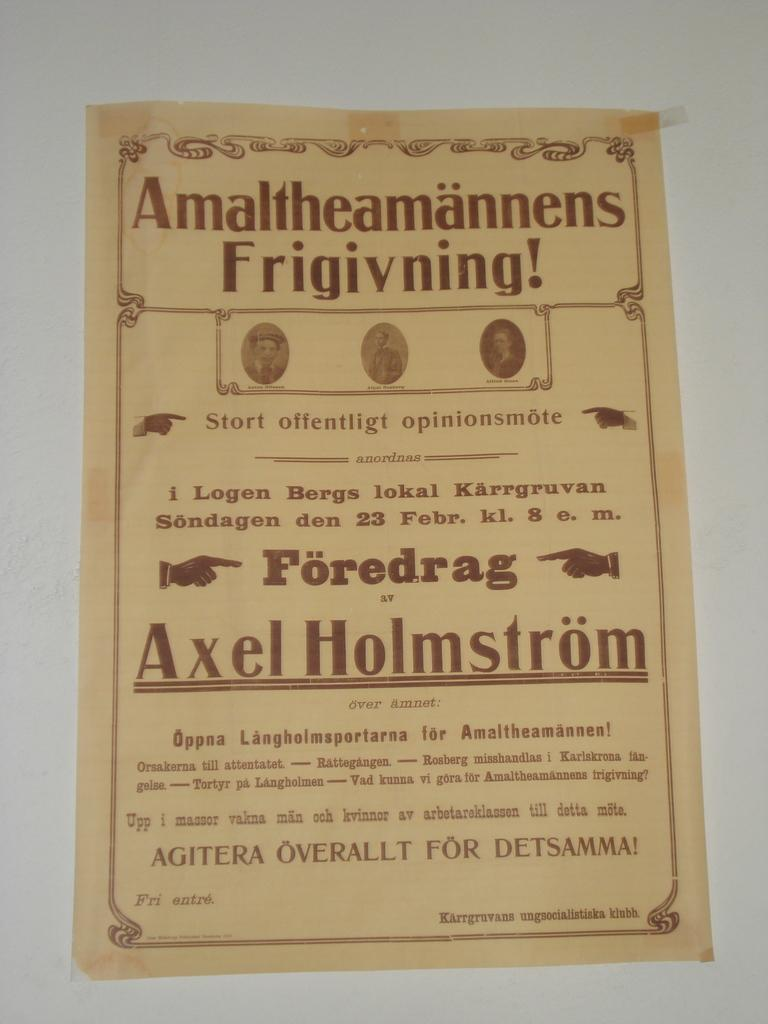<image>
Summarize the visual content of the image. An antique poster sits against a white background that reads "Amaltheamannens Frigivning!" 